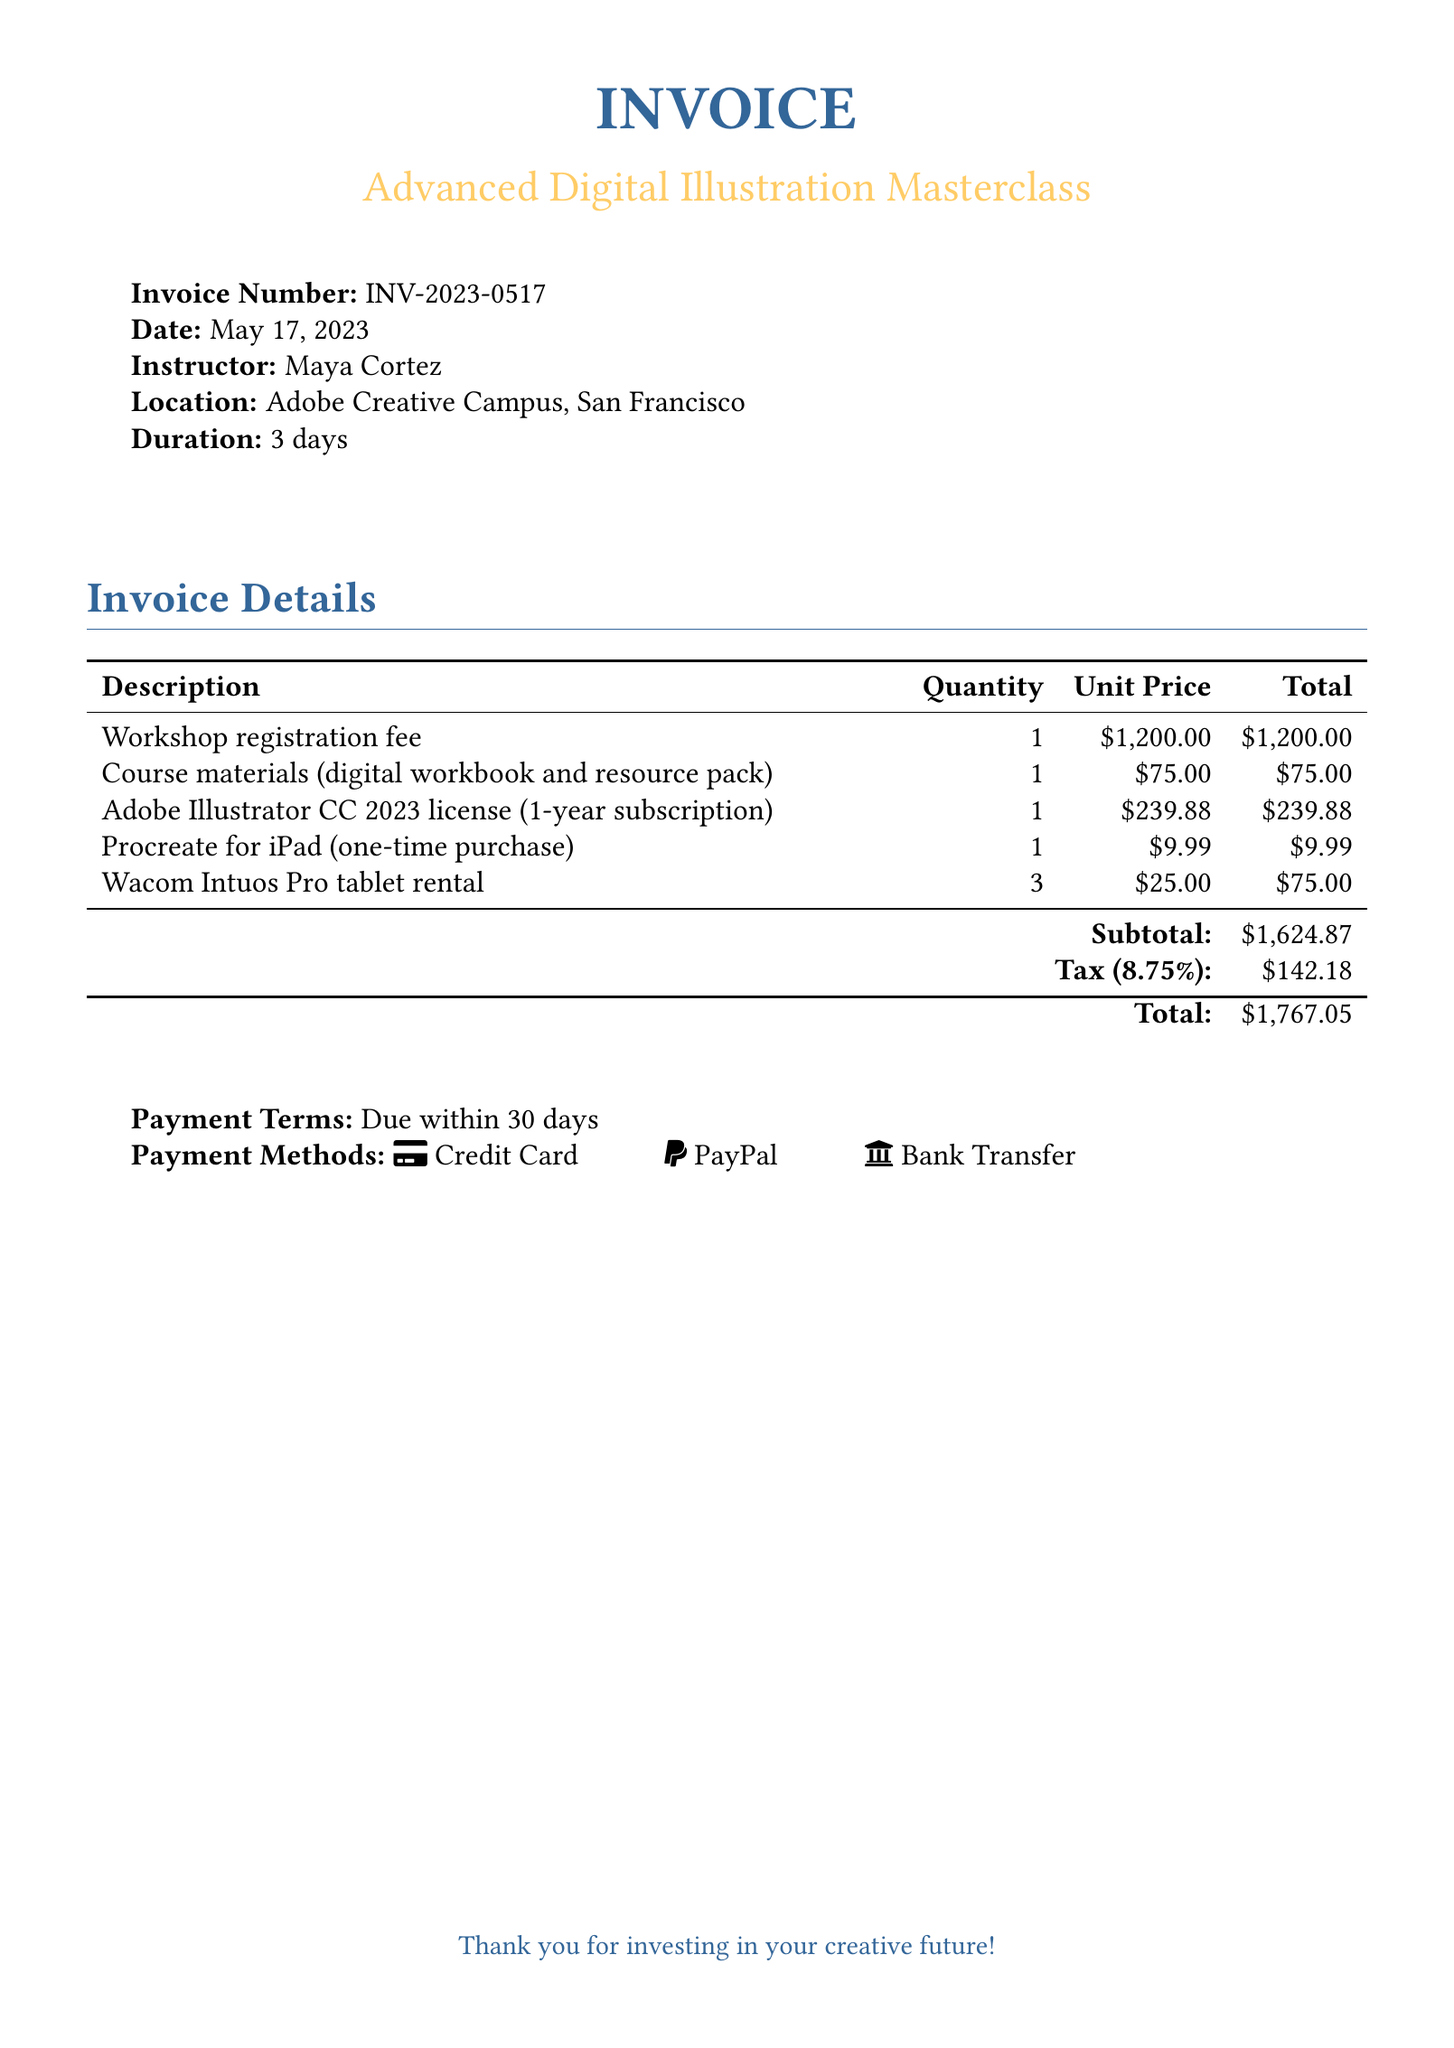What is the invoice number? The invoice number is found in the header of the document under "Invoice Number."
Answer: INV-2023-0517 Who is the instructor of the workshop? The instructor's name is stated in the invoice details section.
Answer: Maya Cortez What is the date of the invoice? The date is listed prominently in the header of the document.
Answer: May 17, 2023 What is the total amount due? The total is provided at the bottom of the invoice in the "Total" row.
Answer: $1,767.05 How long is the workshop duration? The duration is mentioned in the header of the document.
Answer: 3 days What is the subtotal before tax? The subtotal is listed before the tax calculation in the invoice details table.
Answer: $1,624.87 How much is the tax percentage applied? The tax percentage is indicated in the invoice details section.
Answer: 8.75% What payment methods are accepted? The payment methods are listed at the bottom of the invoice under "Payment Methods."
Answer: Credit Card, PayPal, Bank Transfer What is the cost of Adobe Illustrator CC 2023 license? The cost for the software is specified in the invoice details table.
Answer: $239.88 